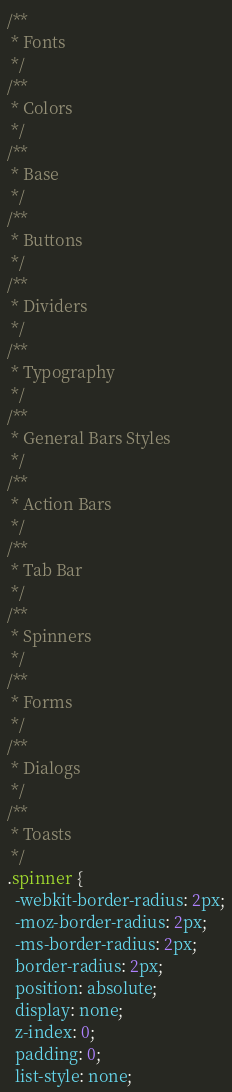Convert code to text. <code><loc_0><loc_0><loc_500><loc_500><_CSS_>/**
 * Fonts
 */
/**
 * Colors
 */
/**
 * Base
 */
/**
 * Buttons
 */
/**
 * Dividers
 */
/**
 * Typography
 */
/**
 * General Bars Styles
 */
/**
 * Action Bars
 */
/**
 * Tab Bar
 */
/**
 * Spinners
 */
/**
 * Forms
 */
/**
 * Dialogs
 */
/**
 * Toasts
 */
.spinner {
  -webkit-border-radius: 2px;
  -moz-border-radius: 2px;
  -ms-border-radius: 2px;
  border-radius: 2px;
  position: absolute;
  display: none;
  z-index: 0;
  padding: 0;
  list-style: none;</code> 